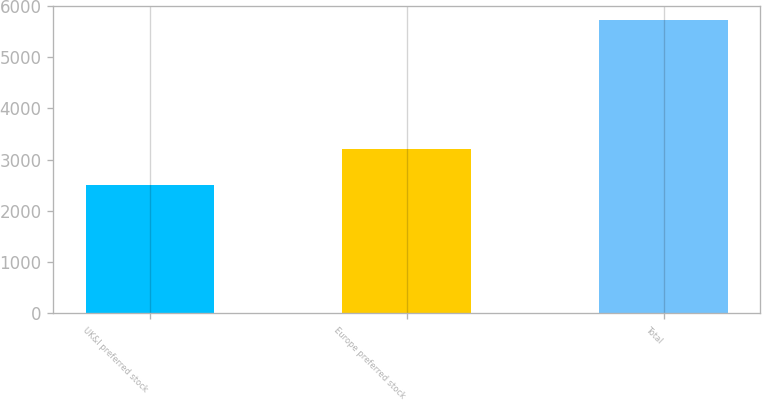Convert chart. <chart><loc_0><loc_0><loc_500><loc_500><bar_chart><fcel>UK&I preferred stock<fcel>Europe preferred stock<fcel>Total<nl><fcel>2516<fcel>3201<fcel>5717<nl></chart> 